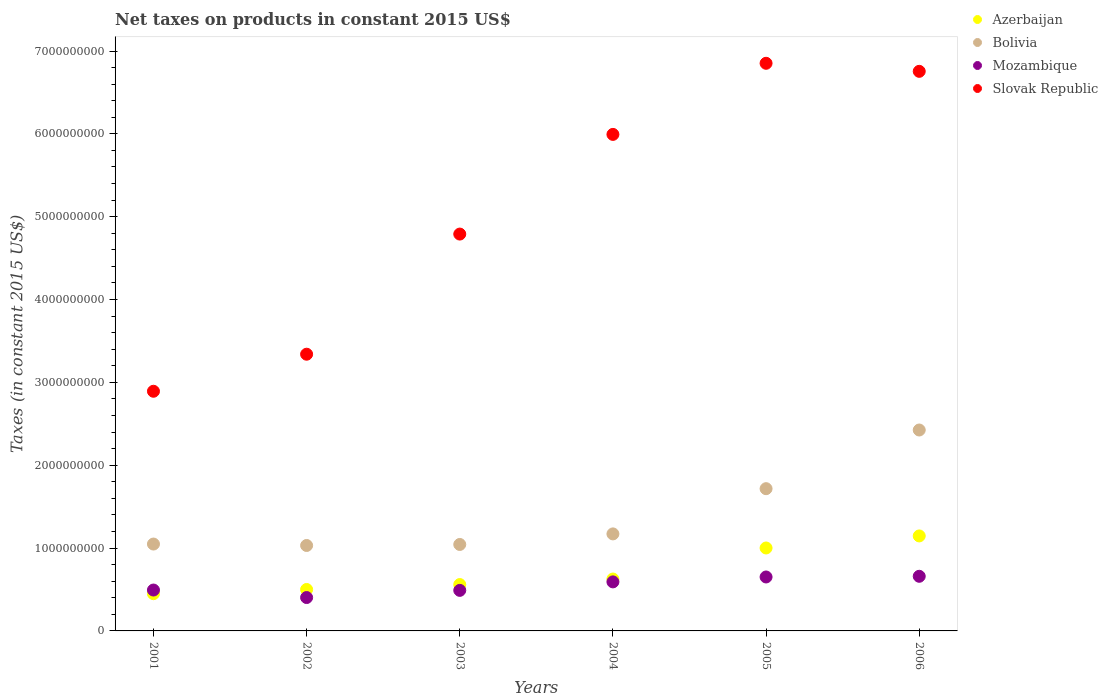Is the number of dotlines equal to the number of legend labels?
Your answer should be very brief. Yes. What is the net taxes on products in Bolivia in 2003?
Offer a very short reply. 1.04e+09. Across all years, what is the maximum net taxes on products in Azerbaijan?
Provide a short and direct response. 1.15e+09. Across all years, what is the minimum net taxes on products in Bolivia?
Your answer should be compact. 1.03e+09. What is the total net taxes on products in Slovak Republic in the graph?
Your answer should be compact. 3.06e+1. What is the difference between the net taxes on products in Mozambique in 2004 and that in 2005?
Give a very brief answer. -5.92e+07. What is the difference between the net taxes on products in Azerbaijan in 2006 and the net taxes on products in Bolivia in 2004?
Provide a succinct answer. -2.45e+07. What is the average net taxes on products in Azerbaijan per year?
Keep it short and to the point. 7.14e+08. In the year 2004, what is the difference between the net taxes on products in Azerbaijan and net taxes on products in Mozambique?
Your answer should be compact. 3.46e+07. In how many years, is the net taxes on products in Azerbaijan greater than 6600000000 US$?
Your answer should be compact. 0. What is the ratio of the net taxes on products in Mozambique in 2002 to that in 2004?
Provide a short and direct response. 0.68. Is the net taxes on products in Mozambique in 2001 less than that in 2004?
Your answer should be very brief. Yes. Is the difference between the net taxes on products in Azerbaijan in 2003 and 2006 greater than the difference between the net taxes on products in Mozambique in 2003 and 2006?
Keep it short and to the point. No. What is the difference between the highest and the second highest net taxes on products in Slovak Republic?
Offer a very short reply. 9.72e+07. What is the difference between the highest and the lowest net taxes on products in Mozambique?
Keep it short and to the point. 2.56e+08. In how many years, is the net taxes on products in Bolivia greater than the average net taxes on products in Bolivia taken over all years?
Your answer should be very brief. 2. Does the net taxes on products in Azerbaijan monotonically increase over the years?
Make the answer very short. Yes. Is the net taxes on products in Mozambique strictly greater than the net taxes on products in Bolivia over the years?
Your response must be concise. No. How many dotlines are there?
Make the answer very short. 4. How many years are there in the graph?
Offer a terse response. 6. What is the difference between two consecutive major ticks on the Y-axis?
Your response must be concise. 1.00e+09. Are the values on the major ticks of Y-axis written in scientific E-notation?
Your answer should be compact. No. Does the graph contain any zero values?
Your response must be concise. No. Where does the legend appear in the graph?
Your response must be concise. Top right. How are the legend labels stacked?
Your answer should be compact. Vertical. What is the title of the graph?
Provide a short and direct response. Net taxes on products in constant 2015 US$. Does "Malta" appear as one of the legend labels in the graph?
Provide a short and direct response. No. What is the label or title of the Y-axis?
Give a very brief answer. Taxes (in constant 2015 US$). What is the Taxes (in constant 2015 US$) of Azerbaijan in 2001?
Offer a terse response. 4.49e+08. What is the Taxes (in constant 2015 US$) of Bolivia in 2001?
Make the answer very short. 1.05e+09. What is the Taxes (in constant 2015 US$) in Mozambique in 2001?
Your answer should be compact. 4.94e+08. What is the Taxes (in constant 2015 US$) of Slovak Republic in 2001?
Your answer should be very brief. 2.89e+09. What is the Taxes (in constant 2015 US$) in Azerbaijan in 2002?
Make the answer very short. 5.00e+08. What is the Taxes (in constant 2015 US$) in Bolivia in 2002?
Offer a terse response. 1.03e+09. What is the Taxes (in constant 2015 US$) in Mozambique in 2002?
Give a very brief answer. 4.03e+08. What is the Taxes (in constant 2015 US$) in Slovak Republic in 2002?
Ensure brevity in your answer.  3.34e+09. What is the Taxes (in constant 2015 US$) in Azerbaijan in 2003?
Keep it short and to the point. 5.60e+08. What is the Taxes (in constant 2015 US$) of Bolivia in 2003?
Give a very brief answer. 1.04e+09. What is the Taxes (in constant 2015 US$) in Mozambique in 2003?
Your answer should be very brief. 4.89e+08. What is the Taxes (in constant 2015 US$) of Slovak Republic in 2003?
Give a very brief answer. 4.79e+09. What is the Taxes (in constant 2015 US$) of Azerbaijan in 2004?
Give a very brief answer. 6.27e+08. What is the Taxes (in constant 2015 US$) of Bolivia in 2004?
Keep it short and to the point. 1.17e+09. What is the Taxes (in constant 2015 US$) of Mozambique in 2004?
Give a very brief answer. 5.92e+08. What is the Taxes (in constant 2015 US$) in Slovak Republic in 2004?
Provide a succinct answer. 5.99e+09. What is the Taxes (in constant 2015 US$) in Azerbaijan in 2005?
Your answer should be very brief. 1.00e+09. What is the Taxes (in constant 2015 US$) in Bolivia in 2005?
Your answer should be compact. 1.72e+09. What is the Taxes (in constant 2015 US$) in Mozambique in 2005?
Offer a terse response. 6.51e+08. What is the Taxes (in constant 2015 US$) of Slovak Republic in 2005?
Provide a succinct answer. 6.85e+09. What is the Taxes (in constant 2015 US$) of Azerbaijan in 2006?
Provide a short and direct response. 1.15e+09. What is the Taxes (in constant 2015 US$) of Bolivia in 2006?
Your response must be concise. 2.43e+09. What is the Taxes (in constant 2015 US$) of Mozambique in 2006?
Your answer should be very brief. 6.59e+08. What is the Taxes (in constant 2015 US$) in Slovak Republic in 2006?
Offer a very short reply. 6.75e+09. Across all years, what is the maximum Taxes (in constant 2015 US$) in Azerbaijan?
Keep it short and to the point. 1.15e+09. Across all years, what is the maximum Taxes (in constant 2015 US$) in Bolivia?
Offer a terse response. 2.43e+09. Across all years, what is the maximum Taxes (in constant 2015 US$) of Mozambique?
Offer a very short reply. 6.59e+08. Across all years, what is the maximum Taxes (in constant 2015 US$) in Slovak Republic?
Give a very brief answer. 6.85e+09. Across all years, what is the minimum Taxes (in constant 2015 US$) in Azerbaijan?
Your answer should be compact. 4.49e+08. Across all years, what is the minimum Taxes (in constant 2015 US$) in Bolivia?
Ensure brevity in your answer.  1.03e+09. Across all years, what is the minimum Taxes (in constant 2015 US$) in Mozambique?
Your answer should be very brief. 4.03e+08. Across all years, what is the minimum Taxes (in constant 2015 US$) in Slovak Republic?
Your answer should be very brief. 2.89e+09. What is the total Taxes (in constant 2015 US$) in Azerbaijan in the graph?
Offer a very short reply. 4.28e+09. What is the total Taxes (in constant 2015 US$) of Bolivia in the graph?
Keep it short and to the point. 8.44e+09. What is the total Taxes (in constant 2015 US$) of Mozambique in the graph?
Offer a very short reply. 3.29e+09. What is the total Taxes (in constant 2015 US$) in Slovak Republic in the graph?
Your answer should be very brief. 3.06e+1. What is the difference between the Taxes (in constant 2015 US$) in Azerbaijan in 2001 and that in 2002?
Your answer should be very brief. -5.09e+07. What is the difference between the Taxes (in constant 2015 US$) of Bolivia in 2001 and that in 2002?
Provide a succinct answer. 1.73e+07. What is the difference between the Taxes (in constant 2015 US$) in Mozambique in 2001 and that in 2002?
Your response must be concise. 9.05e+07. What is the difference between the Taxes (in constant 2015 US$) in Slovak Republic in 2001 and that in 2002?
Make the answer very short. -4.47e+08. What is the difference between the Taxes (in constant 2015 US$) of Azerbaijan in 2001 and that in 2003?
Your answer should be compact. -1.10e+08. What is the difference between the Taxes (in constant 2015 US$) in Bolivia in 2001 and that in 2003?
Offer a very short reply. 5.02e+06. What is the difference between the Taxes (in constant 2015 US$) in Mozambique in 2001 and that in 2003?
Keep it short and to the point. 4.09e+06. What is the difference between the Taxes (in constant 2015 US$) in Slovak Republic in 2001 and that in 2003?
Provide a succinct answer. -1.90e+09. What is the difference between the Taxes (in constant 2015 US$) of Azerbaijan in 2001 and that in 2004?
Ensure brevity in your answer.  -1.77e+08. What is the difference between the Taxes (in constant 2015 US$) of Bolivia in 2001 and that in 2004?
Your answer should be compact. -1.23e+08. What is the difference between the Taxes (in constant 2015 US$) of Mozambique in 2001 and that in 2004?
Your answer should be very brief. -9.84e+07. What is the difference between the Taxes (in constant 2015 US$) in Slovak Republic in 2001 and that in 2004?
Give a very brief answer. -3.10e+09. What is the difference between the Taxes (in constant 2015 US$) in Azerbaijan in 2001 and that in 2005?
Provide a succinct answer. -5.52e+08. What is the difference between the Taxes (in constant 2015 US$) in Bolivia in 2001 and that in 2005?
Provide a short and direct response. -6.68e+08. What is the difference between the Taxes (in constant 2015 US$) of Mozambique in 2001 and that in 2005?
Offer a terse response. -1.58e+08. What is the difference between the Taxes (in constant 2015 US$) of Slovak Republic in 2001 and that in 2005?
Your answer should be compact. -3.96e+09. What is the difference between the Taxes (in constant 2015 US$) of Azerbaijan in 2001 and that in 2006?
Offer a very short reply. -6.97e+08. What is the difference between the Taxes (in constant 2015 US$) in Bolivia in 2001 and that in 2006?
Your answer should be compact. -1.38e+09. What is the difference between the Taxes (in constant 2015 US$) of Mozambique in 2001 and that in 2006?
Provide a short and direct response. -1.66e+08. What is the difference between the Taxes (in constant 2015 US$) in Slovak Republic in 2001 and that in 2006?
Make the answer very short. -3.86e+09. What is the difference between the Taxes (in constant 2015 US$) of Azerbaijan in 2002 and that in 2003?
Provide a succinct answer. -5.95e+07. What is the difference between the Taxes (in constant 2015 US$) in Bolivia in 2002 and that in 2003?
Your answer should be compact. -1.23e+07. What is the difference between the Taxes (in constant 2015 US$) of Mozambique in 2002 and that in 2003?
Offer a terse response. -8.65e+07. What is the difference between the Taxes (in constant 2015 US$) of Slovak Republic in 2002 and that in 2003?
Ensure brevity in your answer.  -1.45e+09. What is the difference between the Taxes (in constant 2015 US$) in Azerbaijan in 2002 and that in 2004?
Keep it short and to the point. -1.26e+08. What is the difference between the Taxes (in constant 2015 US$) in Bolivia in 2002 and that in 2004?
Offer a very short reply. -1.40e+08. What is the difference between the Taxes (in constant 2015 US$) of Mozambique in 2002 and that in 2004?
Provide a succinct answer. -1.89e+08. What is the difference between the Taxes (in constant 2015 US$) of Slovak Republic in 2002 and that in 2004?
Keep it short and to the point. -2.65e+09. What is the difference between the Taxes (in constant 2015 US$) of Azerbaijan in 2002 and that in 2005?
Keep it short and to the point. -5.01e+08. What is the difference between the Taxes (in constant 2015 US$) of Bolivia in 2002 and that in 2005?
Offer a terse response. -6.86e+08. What is the difference between the Taxes (in constant 2015 US$) of Mozambique in 2002 and that in 2005?
Provide a succinct answer. -2.48e+08. What is the difference between the Taxes (in constant 2015 US$) in Slovak Republic in 2002 and that in 2005?
Provide a succinct answer. -3.51e+09. What is the difference between the Taxes (in constant 2015 US$) in Azerbaijan in 2002 and that in 2006?
Your answer should be compact. -6.46e+08. What is the difference between the Taxes (in constant 2015 US$) of Bolivia in 2002 and that in 2006?
Your response must be concise. -1.39e+09. What is the difference between the Taxes (in constant 2015 US$) of Mozambique in 2002 and that in 2006?
Your answer should be very brief. -2.56e+08. What is the difference between the Taxes (in constant 2015 US$) of Slovak Republic in 2002 and that in 2006?
Your answer should be compact. -3.41e+09. What is the difference between the Taxes (in constant 2015 US$) of Azerbaijan in 2003 and that in 2004?
Your response must be concise. -6.69e+07. What is the difference between the Taxes (in constant 2015 US$) in Bolivia in 2003 and that in 2004?
Your answer should be compact. -1.28e+08. What is the difference between the Taxes (in constant 2015 US$) in Mozambique in 2003 and that in 2004?
Your answer should be very brief. -1.03e+08. What is the difference between the Taxes (in constant 2015 US$) in Slovak Republic in 2003 and that in 2004?
Keep it short and to the point. -1.20e+09. What is the difference between the Taxes (in constant 2015 US$) in Azerbaijan in 2003 and that in 2005?
Ensure brevity in your answer.  -4.41e+08. What is the difference between the Taxes (in constant 2015 US$) in Bolivia in 2003 and that in 2005?
Make the answer very short. -6.73e+08. What is the difference between the Taxes (in constant 2015 US$) in Mozambique in 2003 and that in 2005?
Keep it short and to the point. -1.62e+08. What is the difference between the Taxes (in constant 2015 US$) of Slovak Republic in 2003 and that in 2005?
Offer a terse response. -2.06e+09. What is the difference between the Taxes (in constant 2015 US$) in Azerbaijan in 2003 and that in 2006?
Provide a short and direct response. -5.87e+08. What is the difference between the Taxes (in constant 2015 US$) of Bolivia in 2003 and that in 2006?
Your answer should be compact. -1.38e+09. What is the difference between the Taxes (in constant 2015 US$) of Mozambique in 2003 and that in 2006?
Your answer should be compact. -1.70e+08. What is the difference between the Taxes (in constant 2015 US$) in Slovak Republic in 2003 and that in 2006?
Make the answer very short. -1.96e+09. What is the difference between the Taxes (in constant 2015 US$) in Azerbaijan in 2004 and that in 2005?
Provide a short and direct response. -3.75e+08. What is the difference between the Taxes (in constant 2015 US$) in Bolivia in 2004 and that in 2005?
Your answer should be very brief. -5.46e+08. What is the difference between the Taxes (in constant 2015 US$) of Mozambique in 2004 and that in 2005?
Provide a short and direct response. -5.92e+07. What is the difference between the Taxes (in constant 2015 US$) in Slovak Republic in 2004 and that in 2005?
Your answer should be compact. -8.58e+08. What is the difference between the Taxes (in constant 2015 US$) of Azerbaijan in 2004 and that in 2006?
Provide a succinct answer. -5.20e+08. What is the difference between the Taxes (in constant 2015 US$) of Bolivia in 2004 and that in 2006?
Provide a short and direct response. -1.25e+09. What is the difference between the Taxes (in constant 2015 US$) in Mozambique in 2004 and that in 2006?
Keep it short and to the point. -6.74e+07. What is the difference between the Taxes (in constant 2015 US$) of Slovak Republic in 2004 and that in 2006?
Your response must be concise. -7.61e+08. What is the difference between the Taxes (in constant 2015 US$) of Azerbaijan in 2005 and that in 2006?
Ensure brevity in your answer.  -1.45e+08. What is the difference between the Taxes (in constant 2015 US$) of Bolivia in 2005 and that in 2006?
Ensure brevity in your answer.  -7.08e+08. What is the difference between the Taxes (in constant 2015 US$) in Mozambique in 2005 and that in 2006?
Offer a terse response. -8.25e+06. What is the difference between the Taxes (in constant 2015 US$) in Slovak Republic in 2005 and that in 2006?
Offer a very short reply. 9.72e+07. What is the difference between the Taxes (in constant 2015 US$) of Azerbaijan in 2001 and the Taxes (in constant 2015 US$) of Bolivia in 2002?
Provide a short and direct response. -5.82e+08. What is the difference between the Taxes (in constant 2015 US$) of Azerbaijan in 2001 and the Taxes (in constant 2015 US$) of Mozambique in 2002?
Keep it short and to the point. 4.62e+07. What is the difference between the Taxes (in constant 2015 US$) in Azerbaijan in 2001 and the Taxes (in constant 2015 US$) in Slovak Republic in 2002?
Make the answer very short. -2.89e+09. What is the difference between the Taxes (in constant 2015 US$) in Bolivia in 2001 and the Taxes (in constant 2015 US$) in Mozambique in 2002?
Your answer should be very brief. 6.46e+08. What is the difference between the Taxes (in constant 2015 US$) of Bolivia in 2001 and the Taxes (in constant 2015 US$) of Slovak Republic in 2002?
Provide a succinct answer. -2.29e+09. What is the difference between the Taxes (in constant 2015 US$) of Mozambique in 2001 and the Taxes (in constant 2015 US$) of Slovak Republic in 2002?
Give a very brief answer. -2.85e+09. What is the difference between the Taxes (in constant 2015 US$) in Azerbaijan in 2001 and the Taxes (in constant 2015 US$) in Bolivia in 2003?
Your response must be concise. -5.94e+08. What is the difference between the Taxes (in constant 2015 US$) of Azerbaijan in 2001 and the Taxes (in constant 2015 US$) of Mozambique in 2003?
Ensure brevity in your answer.  -4.02e+07. What is the difference between the Taxes (in constant 2015 US$) of Azerbaijan in 2001 and the Taxes (in constant 2015 US$) of Slovak Republic in 2003?
Provide a succinct answer. -4.34e+09. What is the difference between the Taxes (in constant 2015 US$) of Bolivia in 2001 and the Taxes (in constant 2015 US$) of Mozambique in 2003?
Offer a terse response. 5.59e+08. What is the difference between the Taxes (in constant 2015 US$) in Bolivia in 2001 and the Taxes (in constant 2015 US$) in Slovak Republic in 2003?
Give a very brief answer. -3.74e+09. What is the difference between the Taxes (in constant 2015 US$) of Mozambique in 2001 and the Taxes (in constant 2015 US$) of Slovak Republic in 2003?
Offer a very short reply. -4.30e+09. What is the difference between the Taxes (in constant 2015 US$) in Azerbaijan in 2001 and the Taxes (in constant 2015 US$) in Bolivia in 2004?
Offer a terse response. -7.22e+08. What is the difference between the Taxes (in constant 2015 US$) of Azerbaijan in 2001 and the Taxes (in constant 2015 US$) of Mozambique in 2004?
Offer a terse response. -1.43e+08. What is the difference between the Taxes (in constant 2015 US$) in Azerbaijan in 2001 and the Taxes (in constant 2015 US$) in Slovak Republic in 2004?
Give a very brief answer. -5.54e+09. What is the difference between the Taxes (in constant 2015 US$) of Bolivia in 2001 and the Taxes (in constant 2015 US$) of Mozambique in 2004?
Provide a succinct answer. 4.57e+08. What is the difference between the Taxes (in constant 2015 US$) of Bolivia in 2001 and the Taxes (in constant 2015 US$) of Slovak Republic in 2004?
Provide a succinct answer. -4.94e+09. What is the difference between the Taxes (in constant 2015 US$) of Mozambique in 2001 and the Taxes (in constant 2015 US$) of Slovak Republic in 2004?
Give a very brief answer. -5.50e+09. What is the difference between the Taxes (in constant 2015 US$) of Azerbaijan in 2001 and the Taxes (in constant 2015 US$) of Bolivia in 2005?
Give a very brief answer. -1.27e+09. What is the difference between the Taxes (in constant 2015 US$) of Azerbaijan in 2001 and the Taxes (in constant 2015 US$) of Mozambique in 2005?
Your answer should be compact. -2.02e+08. What is the difference between the Taxes (in constant 2015 US$) in Azerbaijan in 2001 and the Taxes (in constant 2015 US$) in Slovak Republic in 2005?
Offer a very short reply. -6.40e+09. What is the difference between the Taxes (in constant 2015 US$) of Bolivia in 2001 and the Taxes (in constant 2015 US$) of Mozambique in 2005?
Offer a terse response. 3.97e+08. What is the difference between the Taxes (in constant 2015 US$) in Bolivia in 2001 and the Taxes (in constant 2015 US$) in Slovak Republic in 2005?
Your answer should be very brief. -5.80e+09. What is the difference between the Taxes (in constant 2015 US$) in Mozambique in 2001 and the Taxes (in constant 2015 US$) in Slovak Republic in 2005?
Offer a terse response. -6.36e+09. What is the difference between the Taxes (in constant 2015 US$) in Azerbaijan in 2001 and the Taxes (in constant 2015 US$) in Bolivia in 2006?
Keep it short and to the point. -1.98e+09. What is the difference between the Taxes (in constant 2015 US$) of Azerbaijan in 2001 and the Taxes (in constant 2015 US$) of Mozambique in 2006?
Ensure brevity in your answer.  -2.10e+08. What is the difference between the Taxes (in constant 2015 US$) of Azerbaijan in 2001 and the Taxes (in constant 2015 US$) of Slovak Republic in 2006?
Your answer should be compact. -6.31e+09. What is the difference between the Taxes (in constant 2015 US$) in Bolivia in 2001 and the Taxes (in constant 2015 US$) in Mozambique in 2006?
Ensure brevity in your answer.  3.89e+08. What is the difference between the Taxes (in constant 2015 US$) of Bolivia in 2001 and the Taxes (in constant 2015 US$) of Slovak Republic in 2006?
Your response must be concise. -5.71e+09. What is the difference between the Taxes (in constant 2015 US$) of Mozambique in 2001 and the Taxes (in constant 2015 US$) of Slovak Republic in 2006?
Ensure brevity in your answer.  -6.26e+09. What is the difference between the Taxes (in constant 2015 US$) in Azerbaijan in 2002 and the Taxes (in constant 2015 US$) in Bolivia in 2003?
Your response must be concise. -5.43e+08. What is the difference between the Taxes (in constant 2015 US$) of Azerbaijan in 2002 and the Taxes (in constant 2015 US$) of Mozambique in 2003?
Give a very brief answer. 1.07e+07. What is the difference between the Taxes (in constant 2015 US$) in Azerbaijan in 2002 and the Taxes (in constant 2015 US$) in Slovak Republic in 2003?
Provide a succinct answer. -4.29e+09. What is the difference between the Taxes (in constant 2015 US$) of Bolivia in 2002 and the Taxes (in constant 2015 US$) of Mozambique in 2003?
Ensure brevity in your answer.  5.42e+08. What is the difference between the Taxes (in constant 2015 US$) in Bolivia in 2002 and the Taxes (in constant 2015 US$) in Slovak Republic in 2003?
Ensure brevity in your answer.  -3.76e+09. What is the difference between the Taxes (in constant 2015 US$) in Mozambique in 2002 and the Taxes (in constant 2015 US$) in Slovak Republic in 2003?
Your answer should be compact. -4.39e+09. What is the difference between the Taxes (in constant 2015 US$) in Azerbaijan in 2002 and the Taxes (in constant 2015 US$) in Bolivia in 2004?
Your answer should be compact. -6.71e+08. What is the difference between the Taxes (in constant 2015 US$) in Azerbaijan in 2002 and the Taxes (in constant 2015 US$) in Mozambique in 2004?
Offer a terse response. -9.18e+07. What is the difference between the Taxes (in constant 2015 US$) in Azerbaijan in 2002 and the Taxes (in constant 2015 US$) in Slovak Republic in 2004?
Offer a very short reply. -5.49e+09. What is the difference between the Taxes (in constant 2015 US$) in Bolivia in 2002 and the Taxes (in constant 2015 US$) in Mozambique in 2004?
Offer a terse response. 4.39e+08. What is the difference between the Taxes (in constant 2015 US$) of Bolivia in 2002 and the Taxes (in constant 2015 US$) of Slovak Republic in 2004?
Your answer should be compact. -4.96e+09. What is the difference between the Taxes (in constant 2015 US$) of Mozambique in 2002 and the Taxes (in constant 2015 US$) of Slovak Republic in 2004?
Keep it short and to the point. -5.59e+09. What is the difference between the Taxes (in constant 2015 US$) in Azerbaijan in 2002 and the Taxes (in constant 2015 US$) in Bolivia in 2005?
Keep it short and to the point. -1.22e+09. What is the difference between the Taxes (in constant 2015 US$) of Azerbaijan in 2002 and the Taxes (in constant 2015 US$) of Mozambique in 2005?
Keep it short and to the point. -1.51e+08. What is the difference between the Taxes (in constant 2015 US$) of Azerbaijan in 2002 and the Taxes (in constant 2015 US$) of Slovak Republic in 2005?
Your response must be concise. -6.35e+09. What is the difference between the Taxes (in constant 2015 US$) of Bolivia in 2002 and the Taxes (in constant 2015 US$) of Mozambique in 2005?
Make the answer very short. 3.80e+08. What is the difference between the Taxes (in constant 2015 US$) of Bolivia in 2002 and the Taxes (in constant 2015 US$) of Slovak Republic in 2005?
Your answer should be very brief. -5.82e+09. What is the difference between the Taxes (in constant 2015 US$) in Mozambique in 2002 and the Taxes (in constant 2015 US$) in Slovak Republic in 2005?
Make the answer very short. -6.45e+09. What is the difference between the Taxes (in constant 2015 US$) in Azerbaijan in 2002 and the Taxes (in constant 2015 US$) in Bolivia in 2006?
Your response must be concise. -1.92e+09. What is the difference between the Taxes (in constant 2015 US$) of Azerbaijan in 2002 and the Taxes (in constant 2015 US$) of Mozambique in 2006?
Offer a terse response. -1.59e+08. What is the difference between the Taxes (in constant 2015 US$) in Azerbaijan in 2002 and the Taxes (in constant 2015 US$) in Slovak Republic in 2006?
Your answer should be compact. -6.25e+09. What is the difference between the Taxes (in constant 2015 US$) of Bolivia in 2002 and the Taxes (in constant 2015 US$) of Mozambique in 2006?
Keep it short and to the point. 3.72e+08. What is the difference between the Taxes (in constant 2015 US$) of Bolivia in 2002 and the Taxes (in constant 2015 US$) of Slovak Republic in 2006?
Offer a very short reply. -5.72e+09. What is the difference between the Taxes (in constant 2015 US$) of Mozambique in 2002 and the Taxes (in constant 2015 US$) of Slovak Republic in 2006?
Offer a very short reply. -6.35e+09. What is the difference between the Taxes (in constant 2015 US$) in Azerbaijan in 2003 and the Taxes (in constant 2015 US$) in Bolivia in 2004?
Your response must be concise. -6.11e+08. What is the difference between the Taxes (in constant 2015 US$) of Azerbaijan in 2003 and the Taxes (in constant 2015 US$) of Mozambique in 2004?
Make the answer very short. -3.23e+07. What is the difference between the Taxes (in constant 2015 US$) in Azerbaijan in 2003 and the Taxes (in constant 2015 US$) in Slovak Republic in 2004?
Your answer should be compact. -5.43e+09. What is the difference between the Taxes (in constant 2015 US$) in Bolivia in 2003 and the Taxes (in constant 2015 US$) in Mozambique in 2004?
Offer a very short reply. 4.52e+08. What is the difference between the Taxes (in constant 2015 US$) in Bolivia in 2003 and the Taxes (in constant 2015 US$) in Slovak Republic in 2004?
Your response must be concise. -4.95e+09. What is the difference between the Taxes (in constant 2015 US$) in Mozambique in 2003 and the Taxes (in constant 2015 US$) in Slovak Republic in 2004?
Make the answer very short. -5.50e+09. What is the difference between the Taxes (in constant 2015 US$) in Azerbaijan in 2003 and the Taxes (in constant 2015 US$) in Bolivia in 2005?
Provide a succinct answer. -1.16e+09. What is the difference between the Taxes (in constant 2015 US$) of Azerbaijan in 2003 and the Taxes (in constant 2015 US$) of Mozambique in 2005?
Your response must be concise. -9.15e+07. What is the difference between the Taxes (in constant 2015 US$) of Azerbaijan in 2003 and the Taxes (in constant 2015 US$) of Slovak Republic in 2005?
Provide a succinct answer. -6.29e+09. What is the difference between the Taxes (in constant 2015 US$) in Bolivia in 2003 and the Taxes (in constant 2015 US$) in Mozambique in 2005?
Offer a terse response. 3.92e+08. What is the difference between the Taxes (in constant 2015 US$) in Bolivia in 2003 and the Taxes (in constant 2015 US$) in Slovak Republic in 2005?
Your answer should be compact. -5.81e+09. What is the difference between the Taxes (in constant 2015 US$) in Mozambique in 2003 and the Taxes (in constant 2015 US$) in Slovak Republic in 2005?
Provide a short and direct response. -6.36e+09. What is the difference between the Taxes (in constant 2015 US$) of Azerbaijan in 2003 and the Taxes (in constant 2015 US$) of Bolivia in 2006?
Your response must be concise. -1.87e+09. What is the difference between the Taxes (in constant 2015 US$) of Azerbaijan in 2003 and the Taxes (in constant 2015 US$) of Mozambique in 2006?
Provide a succinct answer. -9.97e+07. What is the difference between the Taxes (in constant 2015 US$) of Azerbaijan in 2003 and the Taxes (in constant 2015 US$) of Slovak Republic in 2006?
Ensure brevity in your answer.  -6.19e+09. What is the difference between the Taxes (in constant 2015 US$) in Bolivia in 2003 and the Taxes (in constant 2015 US$) in Mozambique in 2006?
Keep it short and to the point. 3.84e+08. What is the difference between the Taxes (in constant 2015 US$) of Bolivia in 2003 and the Taxes (in constant 2015 US$) of Slovak Republic in 2006?
Give a very brief answer. -5.71e+09. What is the difference between the Taxes (in constant 2015 US$) of Mozambique in 2003 and the Taxes (in constant 2015 US$) of Slovak Republic in 2006?
Make the answer very short. -6.27e+09. What is the difference between the Taxes (in constant 2015 US$) in Azerbaijan in 2004 and the Taxes (in constant 2015 US$) in Bolivia in 2005?
Make the answer very short. -1.09e+09. What is the difference between the Taxes (in constant 2015 US$) of Azerbaijan in 2004 and the Taxes (in constant 2015 US$) of Mozambique in 2005?
Offer a very short reply. -2.46e+07. What is the difference between the Taxes (in constant 2015 US$) in Azerbaijan in 2004 and the Taxes (in constant 2015 US$) in Slovak Republic in 2005?
Your answer should be compact. -6.23e+09. What is the difference between the Taxes (in constant 2015 US$) of Bolivia in 2004 and the Taxes (in constant 2015 US$) of Mozambique in 2005?
Your response must be concise. 5.20e+08. What is the difference between the Taxes (in constant 2015 US$) in Bolivia in 2004 and the Taxes (in constant 2015 US$) in Slovak Republic in 2005?
Ensure brevity in your answer.  -5.68e+09. What is the difference between the Taxes (in constant 2015 US$) in Mozambique in 2004 and the Taxes (in constant 2015 US$) in Slovak Republic in 2005?
Provide a short and direct response. -6.26e+09. What is the difference between the Taxes (in constant 2015 US$) of Azerbaijan in 2004 and the Taxes (in constant 2015 US$) of Bolivia in 2006?
Give a very brief answer. -1.80e+09. What is the difference between the Taxes (in constant 2015 US$) of Azerbaijan in 2004 and the Taxes (in constant 2015 US$) of Mozambique in 2006?
Offer a very short reply. -3.28e+07. What is the difference between the Taxes (in constant 2015 US$) in Azerbaijan in 2004 and the Taxes (in constant 2015 US$) in Slovak Republic in 2006?
Your response must be concise. -6.13e+09. What is the difference between the Taxes (in constant 2015 US$) of Bolivia in 2004 and the Taxes (in constant 2015 US$) of Mozambique in 2006?
Offer a terse response. 5.12e+08. What is the difference between the Taxes (in constant 2015 US$) of Bolivia in 2004 and the Taxes (in constant 2015 US$) of Slovak Republic in 2006?
Keep it short and to the point. -5.58e+09. What is the difference between the Taxes (in constant 2015 US$) of Mozambique in 2004 and the Taxes (in constant 2015 US$) of Slovak Republic in 2006?
Give a very brief answer. -6.16e+09. What is the difference between the Taxes (in constant 2015 US$) in Azerbaijan in 2005 and the Taxes (in constant 2015 US$) in Bolivia in 2006?
Your response must be concise. -1.42e+09. What is the difference between the Taxes (in constant 2015 US$) in Azerbaijan in 2005 and the Taxes (in constant 2015 US$) in Mozambique in 2006?
Your response must be concise. 3.42e+08. What is the difference between the Taxes (in constant 2015 US$) of Azerbaijan in 2005 and the Taxes (in constant 2015 US$) of Slovak Republic in 2006?
Offer a very short reply. -5.75e+09. What is the difference between the Taxes (in constant 2015 US$) of Bolivia in 2005 and the Taxes (in constant 2015 US$) of Mozambique in 2006?
Your answer should be very brief. 1.06e+09. What is the difference between the Taxes (in constant 2015 US$) in Bolivia in 2005 and the Taxes (in constant 2015 US$) in Slovak Republic in 2006?
Your answer should be very brief. -5.04e+09. What is the difference between the Taxes (in constant 2015 US$) of Mozambique in 2005 and the Taxes (in constant 2015 US$) of Slovak Republic in 2006?
Offer a terse response. -6.10e+09. What is the average Taxes (in constant 2015 US$) in Azerbaijan per year?
Offer a very short reply. 7.14e+08. What is the average Taxes (in constant 2015 US$) in Bolivia per year?
Your response must be concise. 1.41e+09. What is the average Taxes (in constant 2015 US$) in Mozambique per year?
Make the answer very short. 5.48e+08. What is the average Taxes (in constant 2015 US$) of Slovak Republic per year?
Make the answer very short. 5.10e+09. In the year 2001, what is the difference between the Taxes (in constant 2015 US$) in Azerbaijan and Taxes (in constant 2015 US$) in Bolivia?
Provide a succinct answer. -5.99e+08. In the year 2001, what is the difference between the Taxes (in constant 2015 US$) of Azerbaijan and Taxes (in constant 2015 US$) of Mozambique?
Offer a terse response. -4.43e+07. In the year 2001, what is the difference between the Taxes (in constant 2015 US$) in Azerbaijan and Taxes (in constant 2015 US$) in Slovak Republic?
Make the answer very short. -2.44e+09. In the year 2001, what is the difference between the Taxes (in constant 2015 US$) of Bolivia and Taxes (in constant 2015 US$) of Mozambique?
Your response must be concise. 5.55e+08. In the year 2001, what is the difference between the Taxes (in constant 2015 US$) of Bolivia and Taxes (in constant 2015 US$) of Slovak Republic?
Provide a short and direct response. -1.84e+09. In the year 2001, what is the difference between the Taxes (in constant 2015 US$) of Mozambique and Taxes (in constant 2015 US$) of Slovak Republic?
Offer a very short reply. -2.40e+09. In the year 2002, what is the difference between the Taxes (in constant 2015 US$) of Azerbaijan and Taxes (in constant 2015 US$) of Bolivia?
Provide a short and direct response. -5.31e+08. In the year 2002, what is the difference between the Taxes (in constant 2015 US$) of Azerbaijan and Taxes (in constant 2015 US$) of Mozambique?
Ensure brevity in your answer.  9.72e+07. In the year 2002, what is the difference between the Taxes (in constant 2015 US$) in Azerbaijan and Taxes (in constant 2015 US$) in Slovak Republic?
Provide a short and direct response. -2.84e+09. In the year 2002, what is the difference between the Taxes (in constant 2015 US$) in Bolivia and Taxes (in constant 2015 US$) in Mozambique?
Offer a very short reply. 6.28e+08. In the year 2002, what is the difference between the Taxes (in constant 2015 US$) of Bolivia and Taxes (in constant 2015 US$) of Slovak Republic?
Offer a very short reply. -2.31e+09. In the year 2002, what is the difference between the Taxes (in constant 2015 US$) in Mozambique and Taxes (in constant 2015 US$) in Slovak Republic?
Your answer should be compact. -2.94e+09. In the year 2003, what is the difference between the Taxes (in constant 2015 US$) in Azerbaijan and Taxes (in constant 2015 US$) in Bolivia?
Make the answer very short. -4.84e+08. In the year 2003, what is the difference between the Taxes (in constant 2015 US$) in Azerbaijan and Taxes (in constant 2015 US$) in Mozambique?
Your answer should be compact. 7.02e+07. In the year 2003, what is the difference between the Taxes (in constant 2015 US$) of Azerbaijan and Taxes (in constant 2015 US$) of Slovak Republic?
Give a very brief answer. -4.23e+09. In the year 2003, what is the difference between the Taxes (in constant 2015 US$) in Bolivia and Taxes (in constant 2015 US$) in Mozambique?
Keep it short and to the point. 5.54e+08. In the year 2003, what is the difference between the Taxes (in constant 2015 US$) of Bolivia and Taxes (in constant 2015 US$) of Slovak Republic?
Give a very brief answer. -3.75e+09. In the year 2003, what is the difference between the Taxes (in constant 2015 US$) of Mozambique and Taxes (in constant 2015 US$) of Slovak Republic?
Ensure brevity in your answer.  -4.30e+09. In the year 2004, what is the difference between the Taxes (in constant 2015 US$) of Azerbaijan and Taxes (in constant 2015 US$) of Bolivia?
Provide a succinct answer. -5.45e+08. In the year 2004, what is the difference between the Taxes (in constant 2015 US$) of Azerbaijan and Taxes (in constant 2015 US$) of Mozambique?
Provide a succinct answer. 3.46e+07. In the year 2004, what is the difference between the Taxes (in constant 2015 US$) in Azerbaijan and Taxes (in constant 2015 US$) in Slovak Republic?
Your response must be concise. -5.37e+09. In the year 2004, what is the difference between the Taxes (in constant 2015 US$) in Bolivia and Taxes (in constant 2015 US$) in Mozambique?
Give a very brief answer. 5.79e+08. In the year 2004, what is the difference between the Taxes (in constant 2015 US$) of Bolivia and Taxes (in constant 2015 US$) of Slovak Republic?
Provide a short and direct response. -4.82e+09. In the year 2004, what is the difference between the Taxes (in constant 2015 US$) in Mozambique and Taxes (in constant 2015 US$) in Slovak Republic?
Provide a succinct answer. -5.40e+09. In the year 2005, what is the difference between the Taxes (in constant 2015 US$) in Azerbaijan and Taxes (in constant 2015 US$) in Bolivia?
Give a very brief answer. -7.16e+08. In the year 2005, what is the difference between the Taxes (in constant 2015 US$) of Azerbaijan and Taxes (in constant 2015 US$) of Mozambique?
Your answer should be very brief. 3.50e+08. In the year 2005, what is the difference between the Taxes (in constant 2015 US$) of Azerbaijan and Taxes (in constant 2015 US$) of Slovak Republic?
Provide a short and direct response. -5.85e+09. In the year 2005, what is the difference between the Taxes (in constant 2015 US$) of Bolivia and Taxes (in constant 2015 US$) of Mozambique?
Provide a short and direct response. 1.07e+09. In the year 2005, what is the difference between the Taxes (in constant 2015 US$) of Bolivia and Taxes (in constant 2015 US$) of Slovak Republic?
Keep it short and to the point. -5.13e+09. In the year 2005, what is the difference between the Taxes (in constant 2015 US$) in Mozambique and Taxes (in constant 2015 US$) in Slovak Republic?
Keep it short and to the point. -6.20e+09. In the year 2006, what is the difference between the Taxes (in constant 2015 US$) of Azerbaijan and Taxes (in constant 2015 US$) of Bolivia?
Ensure brevity in your answer.  -1.28e+09. In the year 2006, what is the difference between the Taxes (in constant 2015 US$) of Azerbaijan and Taxes (in constant 2015 US$) of Mozambique?
Your answer should be compact. 4.87e+08. In the year 2006, what is the difference between the Taxes (in constant 2015 US$) in Azerbaijan and Taxes (in constant 2015 US$) in Slovak Republic?
Offer a terse response. -5.61e+09. In the year 2006, what is the difference between the Taxes (in constant 2015 US$) of Bolivia and Taxes (in constant 2015 US$) of Mozambique?
Your answer should be compact. 1.77e+09. In the year 2006, what is the difference between the Taxes (in constant 2015 US$) of Bolivia and Taxes (in constant 2015 US$) of Slovak Republic?
Your response must be concise. -4.33e+09. In the year 2006, what is the difference between the Taxes (in constant 2015 US$) of Mozambique and Taxes (in constant 2015 US$) of Slovak Republic?
Give a very brief answer. -6.10e+09. What is the ratio of the Taxes (in constant 2015 US$) in Azerbaijan in 2001 to that in 2002?
Offer a very short reply. 0.9. What is the ratio of the Taxes (in constant 2015 US$) in Bolivia in 2001 to that in 2002?
Give a very brief answer. 1.02. What is the ratio of the Taxes (in constant 2015 US$) in Mozambique in 2001 to that in 2002?
Your answer should be very brief. 1.22. What is the ratio of the Taxes (in constant 2015 US$) in Slovak Republic in 2001 to that in 2002?
Your answer should be very brief. 0.87. What is the ratio of the Taxes (in constant 2015 US$) of Azerbaijan in 2001 to that in 2003?
Your answer should be very brief. 0.8. What is the ratio of the Taxes (in constant 2015 US$) in Mozambique in 2001 to that in 2003?
Your answer should be compact. 1.01. What is the ratio of the Taxes (in constant 2015 US$) of Slovak Republic in 2001 to that in 2003?
Offer a very short reply. 0.6. What is the ratio of the Taxes (in constant 2015 US$) in Azerbaijan in 2001 to that in 2004?
Provide a succinct answer. 0.72. What is the ratio of the Taxes (in constant 2015 US$) in Bolivia in 2001 to that in 2004?
Offer a terse response. 0.9. What is the ratio of the Taxes (in constant 2015 US$) in Mozambique in 2001 to that in 2004?
Keep it short and to the point. 0.83. What is the ratio of the Taxes (in constant 2015 US$) in Slovak Republic in 2001 to that in 2004?
Your answer should be compact. 0.48. What is the ratio of the Taxes (in constant 2015 US$) in Azerbaijan in 2001 to that in 2005?
Keep it short and to the point. 0.45. What is the ratio of the Taxes (in constant 2015 US$) in Bolivia in 2001 to that in 2005?
Your answer should be compact. 0.61. What is the ratio of the Taxes (in constant 2015 US$) of Mozambique in 2001 to that in 2005?
Offer a very short reply. 0.76. What is the ratio of the Taxes (in constant 2015 US$) of Slovak Republic in 2001 to that in 2005?
Your response must be concise. 0.42. What is the ratio of the Taxes (in constant 2015 US$) of Azerbaijan in 2001 to that in 2006?
Offer a terse response. 0.39. What is the ratio of the Taxes (in constant 2015 US$) in Bolivia in 2001 to that in 2006?
Provide a succinct answer. 0.43. What is the ratio of the Taxes (in constant 2015 US$) of Mozambique in 2001 to that in 2006?
Provide a short and direct response. 0.75. What is the ratio of the Taxes (in constant 2015 US$) of Slovak Republic in 2001 to that in 2006?
Provide a short and direct response. 0.43. What is the ratio of the Taxes (in constant 2015 US$) of Azerbaijan in 2002 to that in 2003?
Ensure brevity in your answer.  0.89. What is the ratio of the Taxes (in constant 2015 US$) of Bolivia in 2002 to that in 2003?
Ensure brevity in your answer.  0.99. What is the ratio of the Taxes (in constant 2015 US$) of Mozambique in 2002 to that in 2003?
Keep it short and to the point. 0.82. What is the ratio of the Taxes (in constant 2015 US$) in Slovak Republic in 2002 to that in 2003?
Give a very brief answer. 0.7. What is the ratio of the Taxes (in constant 2015 US$) of Azerbaijan in 2002 to that in 2004?
Your answer should be very brief. 0.8. What is the ratio of the Taxes (in constant 2015 US$) of Bolivia in 2002 to that in 2004?
Keep it short and to the point. 0.88. What is the ratio of the Taxes (in constant 2015 US$) of Mozambique in 2002 to that in 2004?
Provide a succinct answer. 0.68. What is the ratio of the Taxes (in constant 2015 US$) of Slovak Republic in 2002 to that in 2004?
Offer a terse response. 0.56. What is the ratio of the Taxes (in constant 2015 US$) of Azerbaijan in 2002 to that in 2005?
Give a very brief answer. 0.5. What is the ratio of the Taxes (in constant 2015 US$) in Bolivia in 2002 to that in 2005?
Your answer should be compact. 0.6. What is the ratio of the Taxes (in constant 2015 US$) of Mozambique in 2002 to that in 2005?
Your answer should be very brief. 0.62. What is the ratio of the Taxes (in constant 2015 US$) in Slovak Republic in 2002 to that in 2005?
Your answer should be compact. 0.49. What is the ratio of the Taxes (in constant 2015 US$) of Azerbaijan in 2002 to that in 2006?
Your answer should be compact. 0.44. What is the ratio of the Taxes (in constant 2015 US$) in Bolivia in 2002 to that in 2006?
Offer a very short reply. 0.43. What is the ratio of the Taxes (in constant 2015 US$) of Mozambique in 2002 to that in 2006?
Offer a terse response. 0.61. What is the ratio of the Taxes (in constant 2015 US$) of Slovak Republic in 2002 to that in 2006?
Your response must be concise. 0.49. What is the ratio of the Taxes (in constant 2015 US$) of Azerbaijan in 2003 to that in 2004?
Offer a very short reply. 0.89. What is the ratio of the Taxes (in constant 2015 US$) in Bolivia in 2003 to that in 2004?
Ensure brevity in your answer.  0.89. What is the ratio of the Taxes (in constant 2015 US$) of Mozambique in 2003 to that in 2004?
Offer a terse response. 0.83. What is the ratio of the Taxes (in constant 2015 US$) in Slovak Republic in 2003 to that in 2004?
Offer a terse response. 0.8. What is the ratio of the Taxes (in constant 2015 US$) of Azerbaijan in 2003 to that in 2005?
Give a very brief answer. 0.56. What is the ratio of the Taxes (in constant 2015 US$) of Bolivia in 2003 to that in 2005?
Your response must be concise. 0.61. What is the ratio of the Taxes (in constant 2015 US$) of Mozambique in 2003 to that in 2005?
Offer a terse response. 0.75. What is the ratio of the Taxes (in constant 2015 US$) in Slovak Republic in 2003 to that in 2005?
Keep it short and to the point. 0.7. What is the ratio of the Taxes (in constant 2015 US$) in Azerbaijan in 2003 to that in 2006?
Your response must be concise. 0.49. What is the ratio of the Taxes (in constant 2015 US$) in Bolivia in 2003 to that in 2006?
Offer a very short reply. 0.43. What is the ratio of the Taxes (in constant 2015 US$) in Mozambique in 2003 to that in 2006?
Offer a terse response. 0.74. What is the ratio of the Taxes (in constant 2015 US$) of Slovak Republic in 2003 to that in 2006?
Offer a very short reply. 0.71. What is the ratio of the Taxes (in constant 2015 US$) of Azerbaijan in 2004 to that in 2005?
Offer a very short reply. 0.63. What is the ratio of the Taxes (in constant 2015 US$) of Bolivia in 2004 to that in 2005?
Your response must be concise. 0.68. What is the ratio of the Taxes (in constant 2015 US$) in Slovak Republic in 2004 to that in 2005?
Make the answer very short. 0.87. What is the ratio of the Taxes (in constant 2015 US$) in Azerbaijan in 2004 to that in 2006?
Offer a terse response. 0.55. What is the ratio of the Taxes (in constant 2015 US$) of Bolivia in 2004 to that in 2006?
Provide a short and direct response. 0.48. What is the ratio of the Taxes (in constant 2015 US$) in Mozambique in 2004 to that in 2006?
Ensure brevity in your answer.  0.9. What is the ratio of the Taxes (in constant 2015 US$) in Slovak Republic in 2004 to that in 2006?
Give a very brief answer. 0.89. What is the ratio of the Taxes (in constant 2015 US$) in Azerbaijan in 2005 to that in 2006?
Keep it short and to the point. 0.87. What is the ratio of the Taxes (in constant 2015 US$) in Bolivia in 2005 to that in 2006?
Provide a succinct answer. 0.71. What is the ratio of the Taxes (in constant 2015 US$) of Mozambique in 2005 to that in 2006?
Your answer should be very brief. 0.99. What is the ratio of the Taxes (in constant 2015 US$) of Slovak Republic in 2005 to that in 2006?
Offer a very short reply. 1.01. What is the difference between the highest and the second highest Taxes (in constant 2015 US$) of Azerbaijan?
Your response must be concise. 1.45e+08. What is the difference between the highest and the second highest Taxes (in constant 2015 US$) of Bolivia?
Offer a terse response. 7.08e+08. What is the difference between the highest and the second highest Taxes (in constant 2015 US$) of Mozambique?
Keep it short and to the point. 8.25e+06. What is the difference between the highest and the second highest Taxes (in constant 2015 US$) in Slovak Republic?
Your answer should be very brief. 9.72e+07. What is the difference between the highest and the lowest Taxes (in constant 2015 US$) in Azerbaijan?
Keep it short and to the point. 6.97e+08. What is the difference between the highest and the lowest Taxes (in constant 2015 US$) of Bolivia?
Offer a very short reply. 1.39e+09. What is the difference between the highest and the lowest Taxes (in constant 2015 US$) in Mozambique?
Offer a very short reply. 2.56e+08. What is the difference between the highest and the lowest Taxes (in constant 2015 US$) in Slovak Republic?
Your answer should be compact. 3.96e+09. 